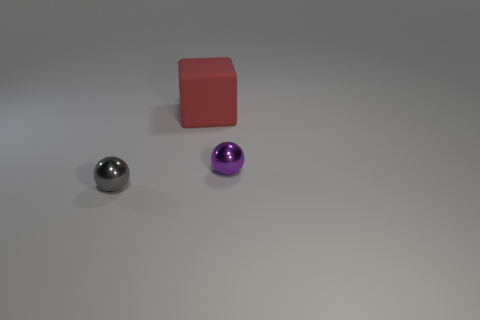Is there anything else that has the same size as the red thing?
Offer a terse response. No. Is the material of the tiny sphere that is on the left side of the purple metallic ball the same as the small purple thing?
Give a very brief answer. Yes. There is a small metal object that is in front of the small metallic object to the right of the big red block; is there a shiny object that is behind it?
Make the answer very short. Yes. What number of spheres are gray objects or shiny things?
Your answer should be very brief. 2. There is a thing that is behind the small purple ball; what material is it?
Keep it short and to the point. Rubber. Is the color of the small object that is to the right of the gray thing the same as the large rubber object that is right of the small gray metal thing?
Offer a very short reply. No. How many things are either tiny purple shiny things or big brown metallic things?
Offer a very short reply. 1. How many other objects are there of the same shape as the small purple object?
Provide a succinct answer. 1. Is the tiny ball right of the tiny gray metal ball made of the same material as the red thing behind the tiny gray thing?
Provide a succinct answer. No. What shape is the thing that is both to the right of the tiny gray shiny sphere and left of the purple shiny thing?
Make the answer very short. Cube. 